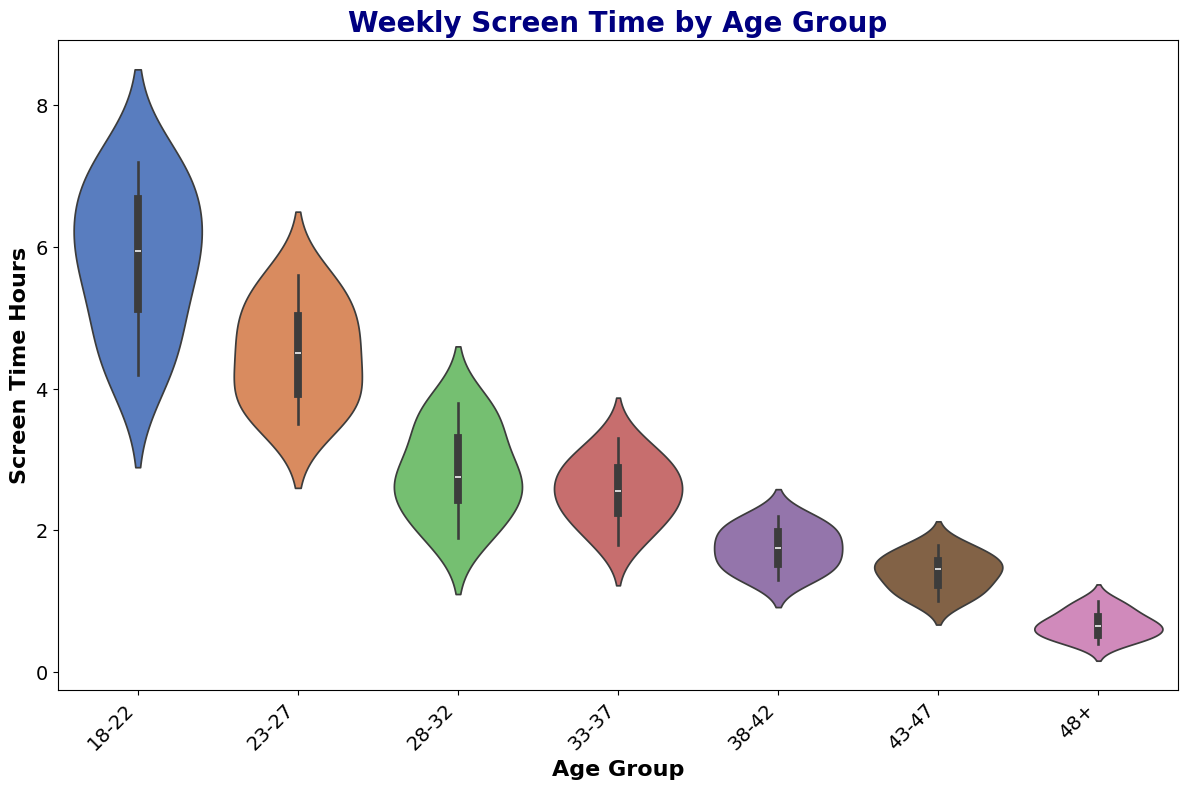Which age group has the highest median screen time? To determine the highest median screen time, observe the horizontal line inside each violin. The line inside the plot for age group 18-22 is at a higher position compared to the other groups.
Answer: 18-22 Is the median screen time for age group 23-27 higher than that for age group 33-37? Compare the positions of the horizontal lines inside the violins of age groups 23-27 and 33-37. The line inside the plot for 23-27 is higher compared to 33-37.
Answer: Yes Which age group has the most spread out screen time data? The width of the violin plot indicates the spread of the data. The plot for the 18-22 age group is wider, indicating a larger spread.
Answer: 18-22 Does the age group 48+ have any outliers in screen time? Outliers are usually represented by dots outside the violin plot. Since there are no dots outside the violin for age group 48+, there are no outliers.
Answer: No Compare the maximum screen time values for age groups 28-32 and 38-42. Which one is higher? The maximum screen time is indicated by the highest point of the violin plot. The highest point for 28-32 is higher than that for 38-42.
Answer: 28-32 What is the approximate range of screen time for age group 43-47? The range is the difference between the highest and lowest points of the violin. The highest point is around 1.8, and the lowest is around 1.0, so the range is approximately 1.8 - 1.0.
Answer: 0.8 Is there a trend in weekly screen time as age increases? Observe the overall positions of the violins from left to right. Screen time generally decreases as age increases from 18-22 to 48+.
Answer: Yes Which age group has the smallest interquartile range (IQR) in screen time? The IQR is the distance between the top and bottom of the box inside the violin. The box for the 48+ age group is the smallest, indicating the smallest IQR.
Answer: 48+ Do any age groups have similar median screen times? Compare the horizontal lines inside each violin. The medians for age groups 38-42 and 43-47 are approximately at the same level.
Answer: 38-42 and 43-47 